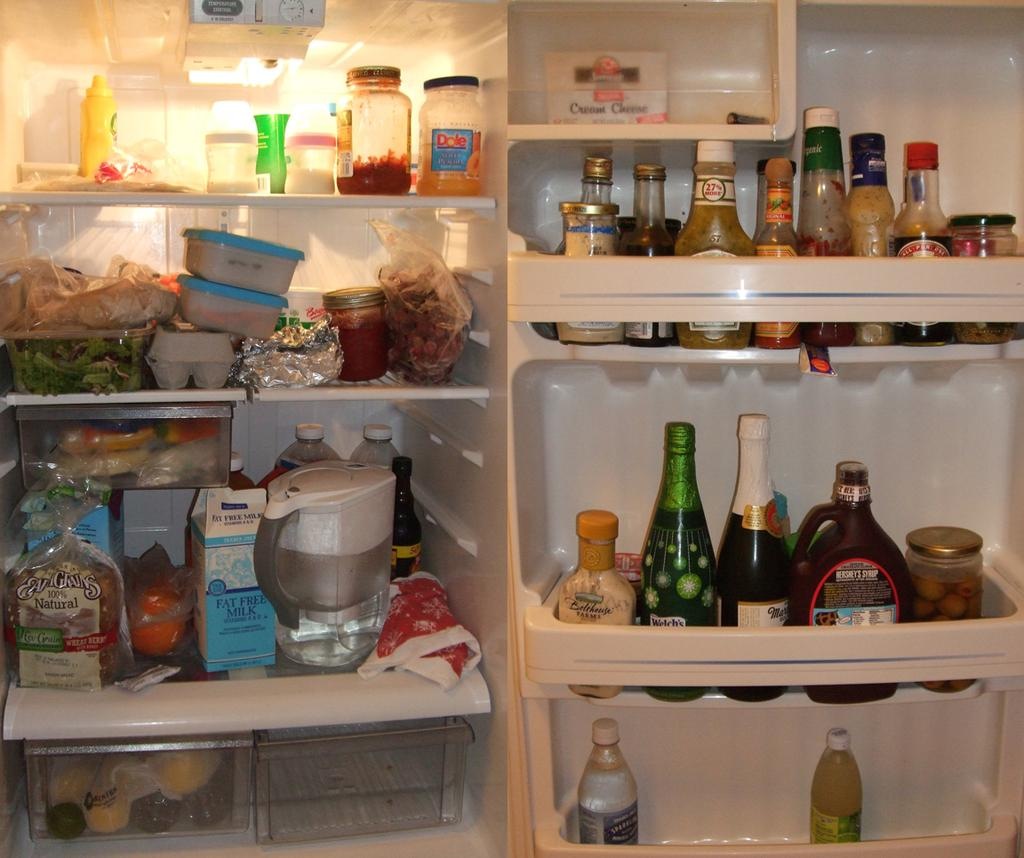<image>
Share a concise interpretation of the image provided. the inside of someone's refrigerator with Hershey's chocolate sauce on one shelf. 